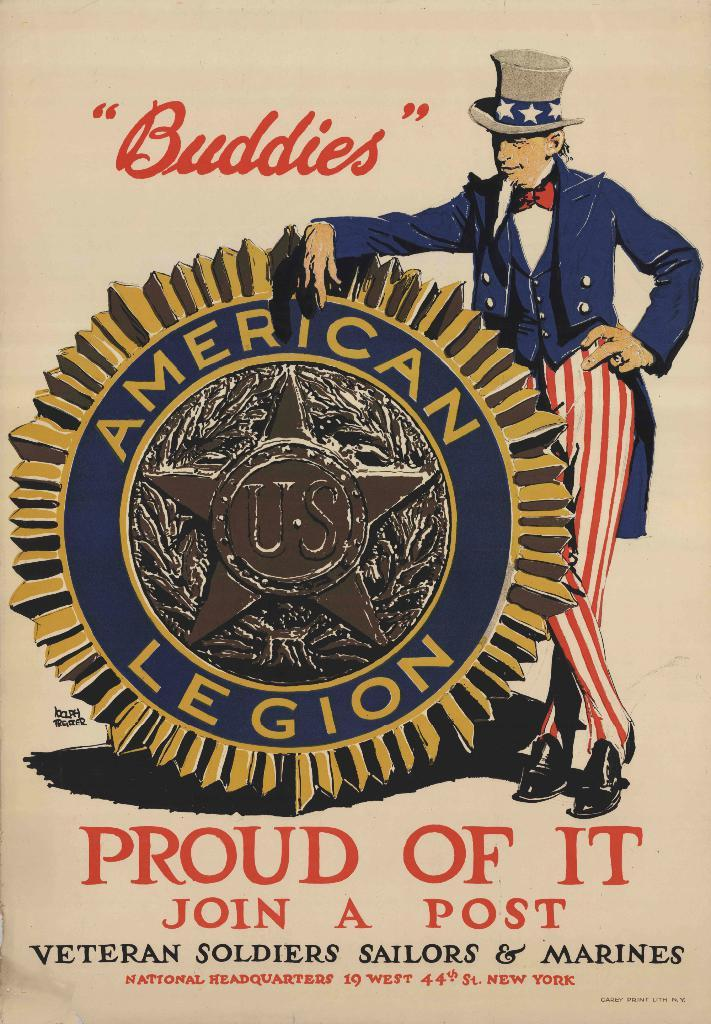Provide a one-sentence caption for the provided image. an American Legion "Buddies" poster saying Proud Of It. 